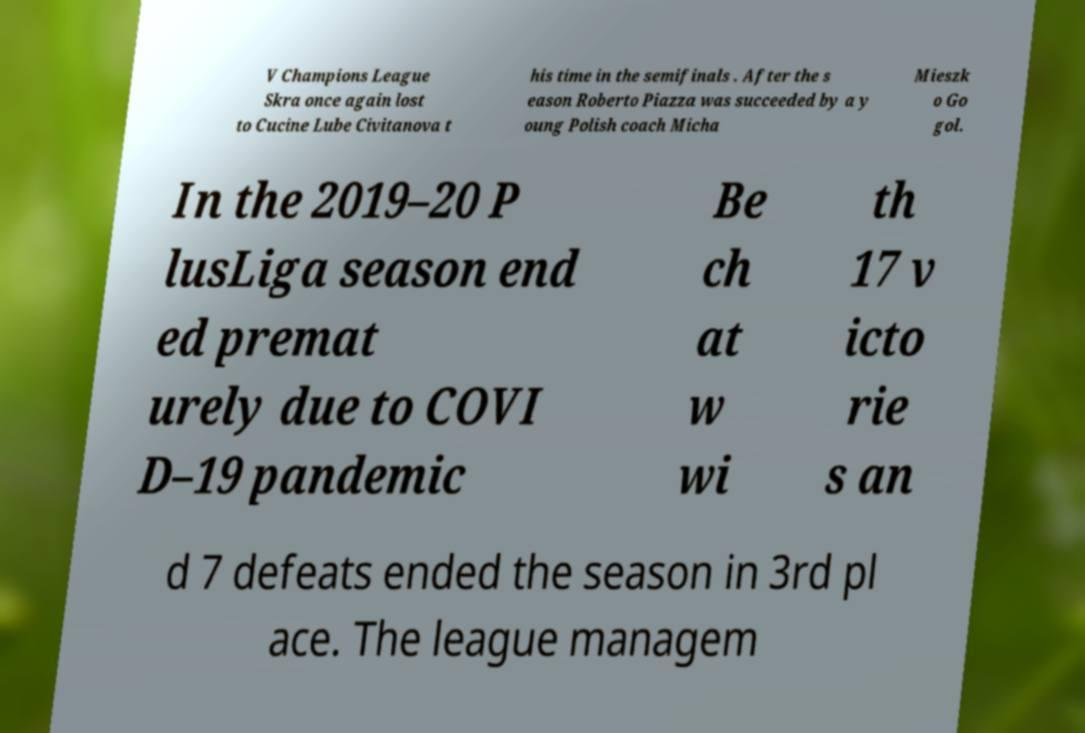Can you read and provide the text displayed in the image?This photo seems to have some interesting text. Can you extract and type it out for me? V Champions League Skra once again lost to Cucine Lube Civitanova t his time in the semifinals . After the s eason Roberto Piazza was succeeded by a y oung Polish coach Micha Mieszk o Go gol. In the 2019–20 P lusLiga season end ed premat urely due to COVI D–19 pandemic Be ch at w wi th 17 v icto rie s an d 7 defeats ended the season in 3rd pl ace. The league managem 